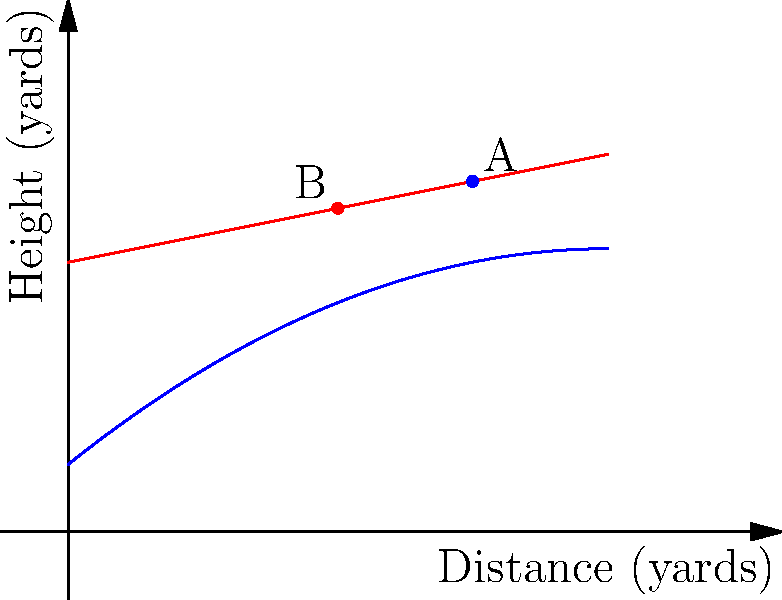As a former football coach, you're analyzing the trajectory of two different passes. The blue curve represents a pass thrown by the starting quarterback, while the red line represents a pass thrown by the backup quarterback. At what distance from the thrower does the starting quarterback's pass (blue curve) reach its maximum height? To find the distance at which the starting quarterback's pass reaches its maximum height, we need to follow these steps:

1. Recognize that the blue curve represents a parabola, which is the typical trajectory of a football pass.

2. Recall that the vertex of a parabola represents its maximum point for an upward-facing parabola.

3. The general form of a quadratic function is $f(x) = ax^2 + bx + c$, where $a < 0$ for an upward-facing parabola.

4. From the graph, we can estimate that the vertex appears to be around 6-8 yards from the thrower.

5. To find the exact x-coordinate of the vertex, we use the formula: $x = -\frac{b}{2a}$

6. From the asymptote code, we can see that the function for the blue curve is $f(x) = -0.05x^2 + 0.8x + 1$

7. Comparing this to the general form, we have $a = -0.05$ and $b = 0.8$

8. Plugging these values into the vertex formula:

   $x = -\frac{0.8}{2(-0.05)} = -\frac{0.8}{-0.1} = 8$ yards

Therefore, the starting quarterback's pass reaches its maximum height at a distance of 8 yards from the thrower.
Answer: 8 yards 